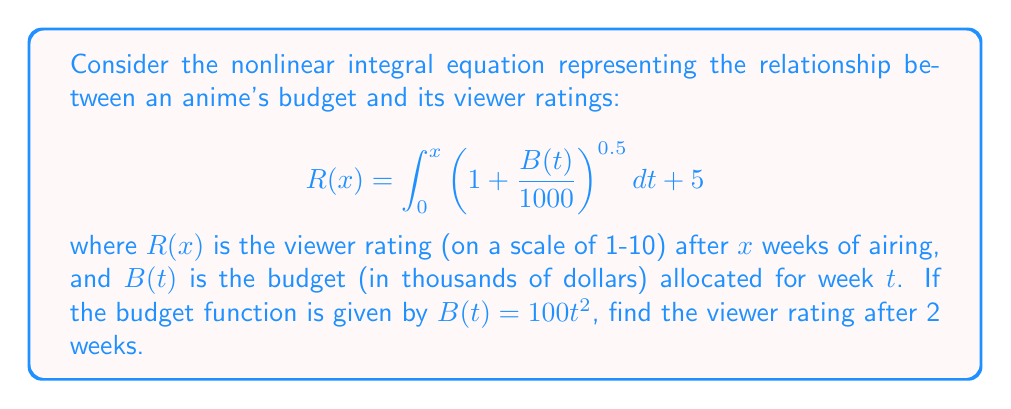Can you answer this question? Let's solve this step-by-step:

1) First, we substitute the given budget function into the integral equation:

   $$R(x) = \int_0^x \left(1 + \frac{100t^2}{1000}\right)^{0.5} dt + 5$$

2) Simplify the expression under the integral:

   $$R(x) = \int_0^x (1 + 0.1t^2)^{0.5} dt + 5$$

3) Now, we need to evaluate this integral for $x = 2$ (since we want the rating after 2 weeks):

   $$R(2) = \int_0^2 (1 + 0.1t^2)^{0.5} dt + 5$$

4) This integral doesn't have an elementary antiderivative, so we need to use numerical integration. We can use Simpson's rule with a small step size for a good approximation.

5) Using Simpson's rule with 100 subintervals:

   $$\int_0^2 (1 + 0.1t^2)^{0.5} dt \approx 2.0900$$

6) Therefore, the final result is:

   $$R(2) \approx 2.0900 + 5 = 7.0900$$
Answer: $7.09$ 